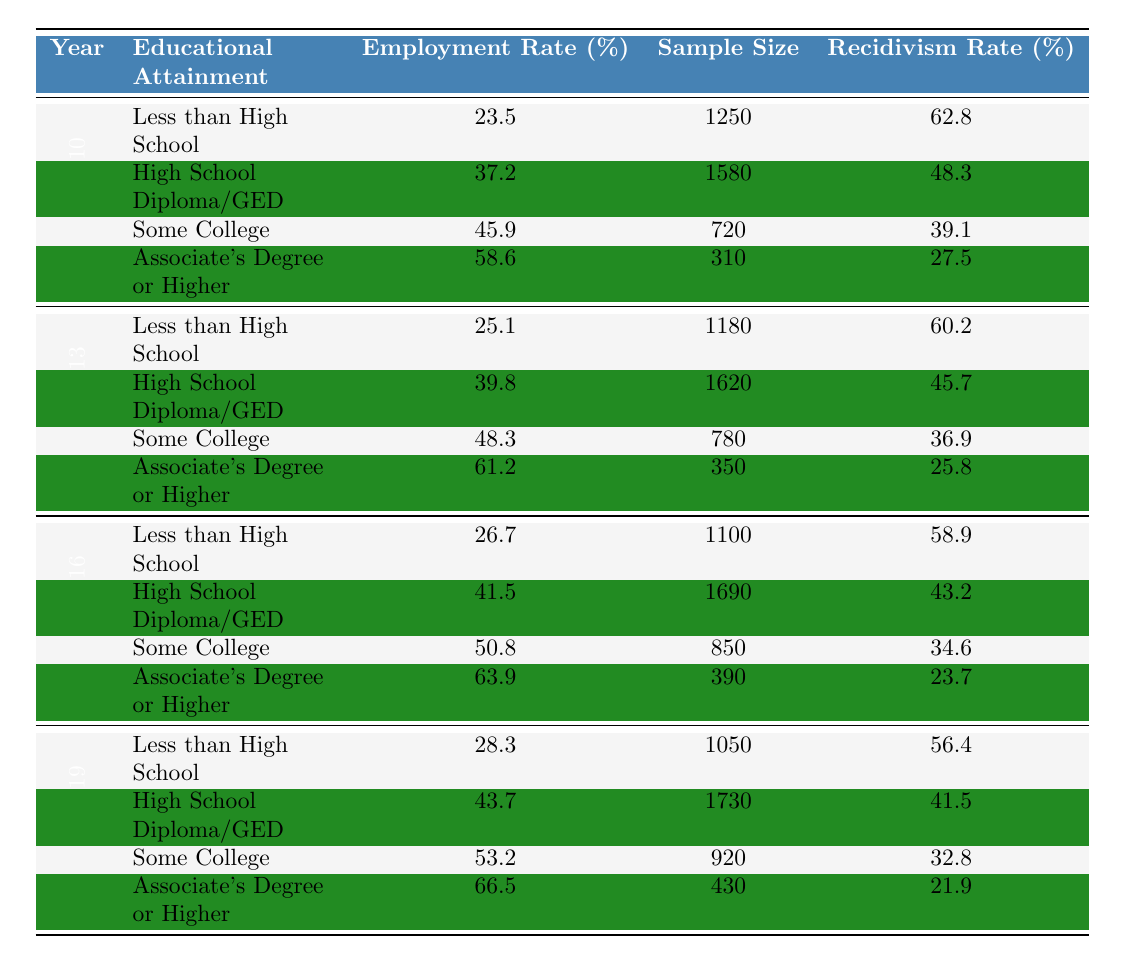What was the employment rate for former inmates with a High School Diploma/GED in 2016? Looking at the table for the year 2016 and the educational attainment category of "High School Diploma/GED," the employment rate is listed as 41.5%.
Answer: 41.5% What is the employment rate for individuals with an Associate's Degree or higher in 2019 compared to 2010? In 2019, the employment rate for those with an Associate's Degree or higher is 66.5%, while in 2010 it was 58.6%. The difference is 66.5% - 58.6% = 7.9%.
Answer: 7.9% Was the recidivism rate for individuals with some college education lower in 2013 than in 2010? In 2010, the recidivism rate for those with some college education was 39.1%. In 2013, it was 36.9%. Since 36.9% is lower than 39.1%, the answer is yes.
Answer: Yes What is the average employment rate across all educational attainments for the year 2019? For 2019, the employment rates are 28.3%, 43.7%, 53.2%, and 66.5%. The average is calculated as (28.3 + 43.7 + 53.2 + 66.5) / 4 = 47.175%.
Answer: 47.175% Which year had the highest employment rate for those with less than a high school education? By examining the employment rates for "Less than High School," we find 23.5% in 2010, 25.1% in 2013, 26.7% in 2016, and 28.3% in 2019. The highest is 28.3% in 2019.
Answer: 2019 How did the sample size for High School Diploma/GED recipients change from 2010 to 2019? In 2010, the sample size was 1580, and in 2019 it increased to 1730. The change in sample size is 1730 - 1580 = 150.
Answer: 150 Is the trend in employment rates for those with higher educational attainment increasing over the years? Looking at the employment rates for "Associate's Degree or Higher" across the years: 58.6% (2010), 61.2% (2013), 63.9% (2016), and 66.5% (2019), there is a clear increase of 7.9% over the four years. Therefore, the trend is increasing.
Answer: Yes What was the relationship between educational attainment and recidivism rate in 2016? In 2016, recidivism rates for "Less than High School" was 58.9%, "High School Diploma/GED" was 43.2%, "Some College" was 34.6%, and "Associate's Degree or Higher" was 23.7%. This shows that as educational attainment increases, recidivism rates decrease.
Answer: Inverse relationship What was the increase in employment rate for individuals with some college education from 2013 to 2019? In 2013, the employment rate for "Some College" was 48.3%, and in 2019 it increased to 53.2%. The increase is 53.2% - 48.3% = 4.9%.
Answer: 4.9% 